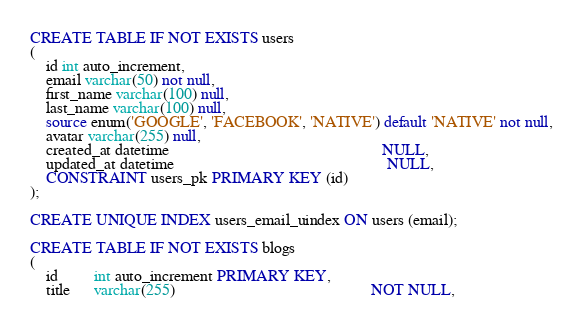<code> <loc_0><loc_0><loc_500><loc_500><_SQL_>CREATE TABLE IF NOT EXISTS users
(
    id int auto_increment,
    email varchar(50) not null,
    first_name varchar(100) null,
    last_name varchar(100) null,
    source enum('GOOGLE', 'FACEBOOK', 'NATIVE') default 'NATIVE' not null,
    avatar varchar(255) null,
    created_at datetime                                                     NULL,
    updated_at datetime                                                     NULL,
    CONSTRAINT users_pk PRIMARY KEY (id)
);

CREATE UNIQUE INDEX users_email_uindex ON users (email);

CREATE TABLE IF NOT EXISTS blogs
(
    id         int auto_increment PRIMARY KEY,
    title      varchar(255)                                                 NOT NULL,</code> 